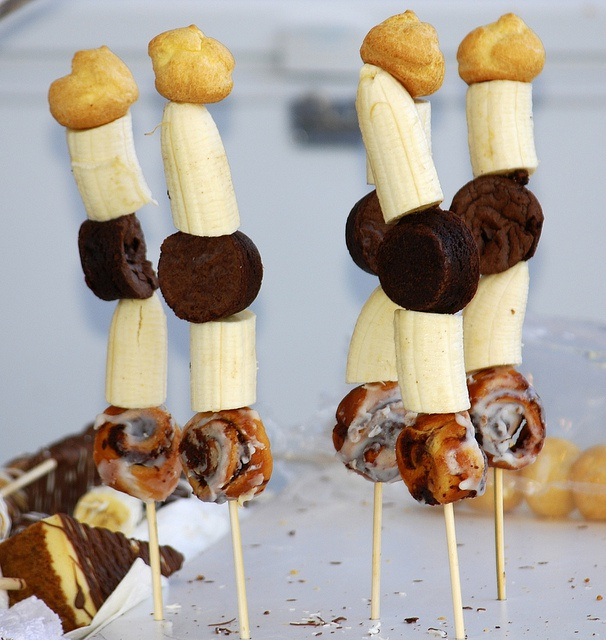Describe the objects in this image and their specific colors. I can see cake in darkgray, maroon, lightgray, tan, and black tones, banana in darkgray, khaki, beige, and tan tones, banana in darkgray, khaki, beige, and tan tones, banana in darkgray, beige, khaki, and tan tones, and donut in darkgray, brown, maroon, gray, and black tones in this image. 